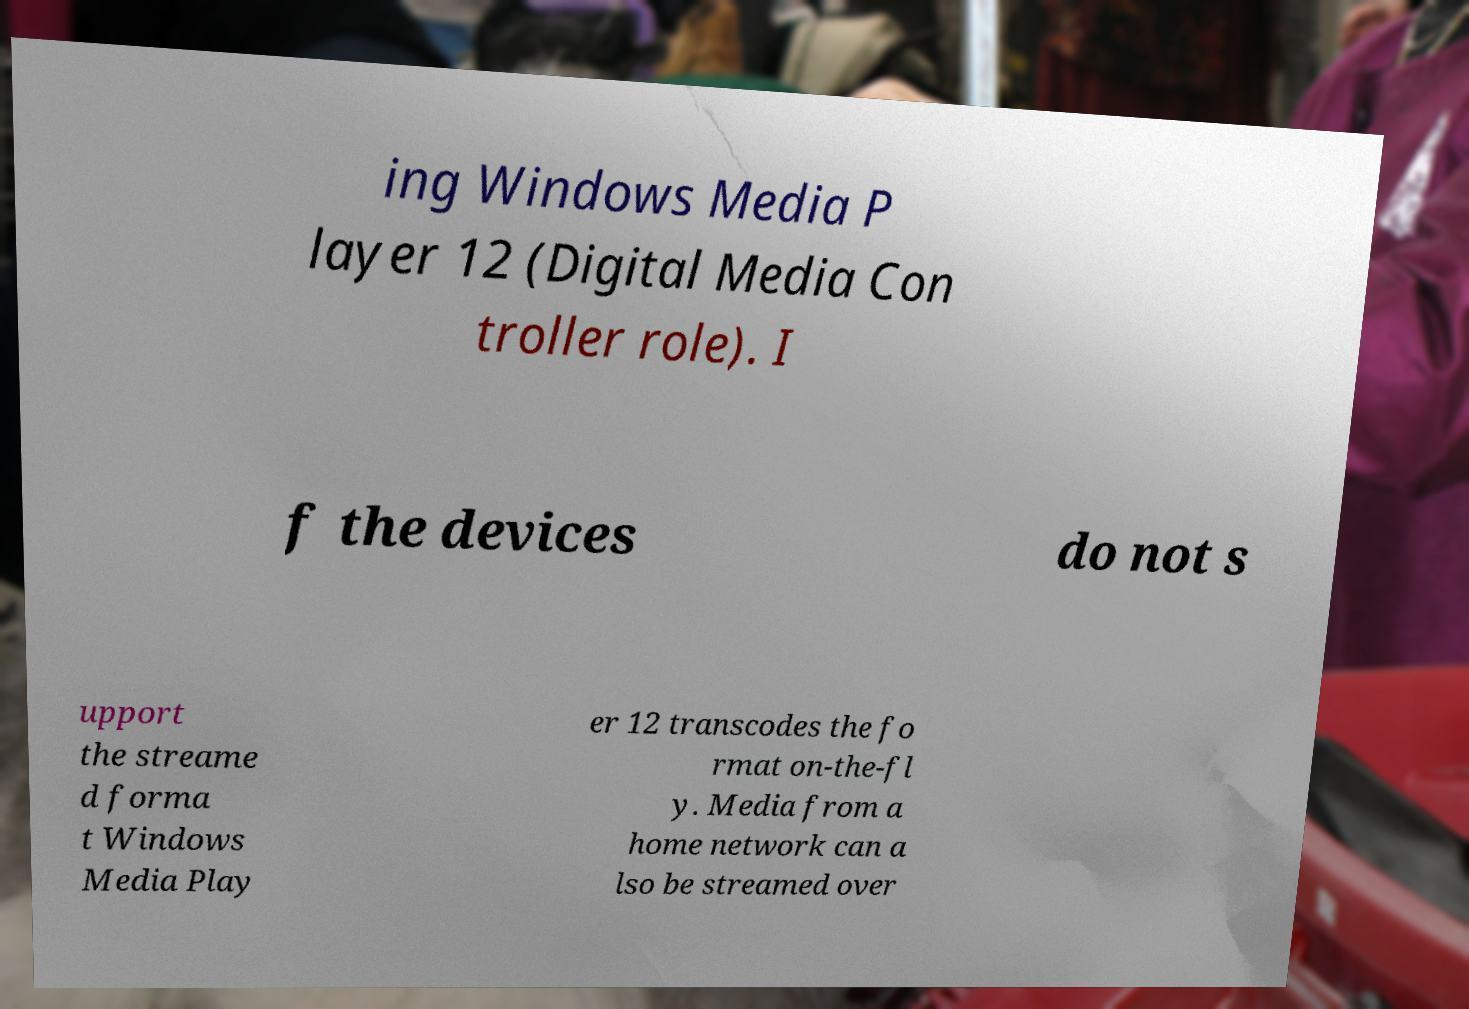Please identify and transcribe the text found in this image. ing Windows Media P layer 12 (Digital Media Con troller role). I f the devices do not s upport the streame d forma t Windows Media Play er 12 transcodes the fo rmat on-the-fl y. Media from a home network can a lso be streamed over 